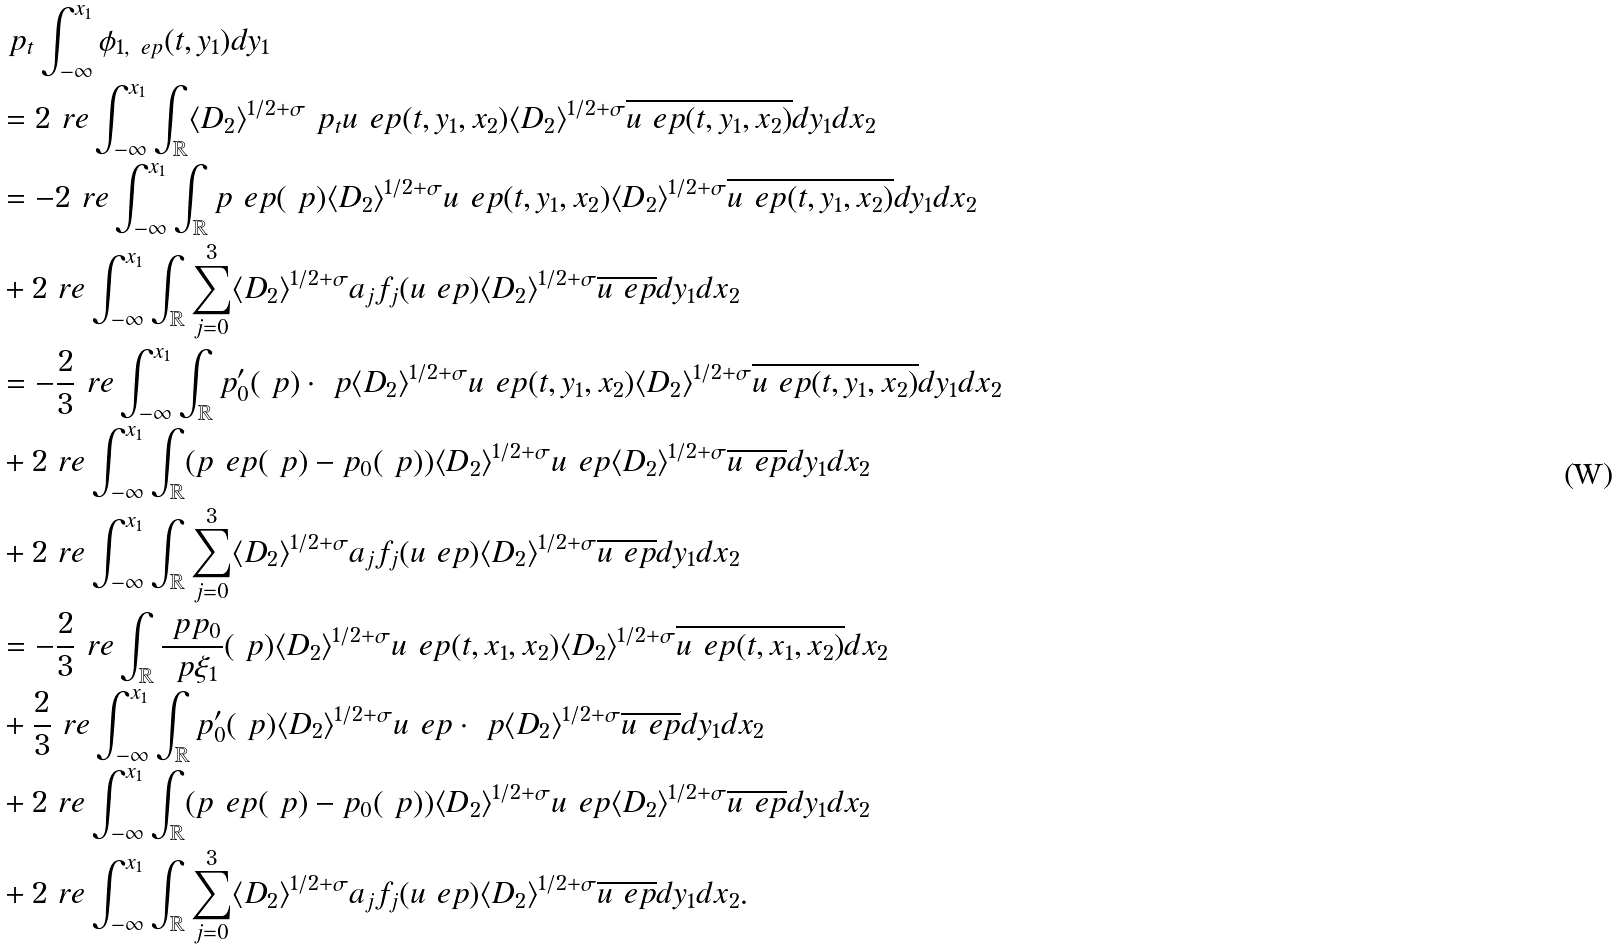<formula> <loc_0><loc_0><loc_500><loc_500>& \ p _ { t } \int _ { - \infty } ^ { x _ { 1 } } \phi _ { 1 , \ e p } ( t , y _ { 1 } ) d y _ { 1 } \\ & = 2 \ r e \int _ { - \infty } ^ { x _ { 1 } } \int _ { \mathbb { R } } \langle { D _ { 2 } } \rangle ^ { 1 / 2 + \sigma } \ p _ { t } u _ { \ } e p ( t , y _ { 1 } , x _ { 2 } ) \langle { D _ { 2 } } \rangle ^ { 1 / 2 + \sigma } \overline { u _ { \ } e p ( t , y _ { 1 } , x _ { 2 } ) } d y _ { 1 } d x _ { 2 } \\ & = - 2 \ r e \int _ { - \infty } ^ { x _ { 1 } } \int _ { \mathbb { R } } p _ { \ } e p ( \ p ) \langle { D _ { 2 } } \rangle ^ { 1 / 2 + \sigma } u _ { \ } e p ( t , y _ { 1 } , x _ { 2 } ) \langle { D _ { 2 } } \rangle ^ { 1 / 2 + \sigma } \overline { u _ { \ } e p ( t , y _ { 1 } , x _ { 2 } ) } d y _ { 1 } d x _ { 2 } \\ & + 2 \ r e \int _ { - \infty } ^ { x _ { 1 } } \int _ { \mathbb { R } } \sum _ { j = 0 } ^ { 3 } \langle { D _ { 2 } } \rangle ^ { 1 / 2 + \sigma } a _ { j } f _ { j } ( u _ { \ } e p ) \langle { D _ { 2 } } \rangle ^ { 1 / 2 + \sigma } \overline { u _ { \ } e p } d y _ { 1 } d x _ { 2 } \\ & = - \frac { 2 } { 3 } \ r e \int _ { - \infty } ^ { x _ { 1 } } \int _ { \mathbb { R } } p _ { 0 } ^ { \prime } ( \ p ) \cdot \ p \langle { D _ { 2 } } \rangle ^ { 1 / 2 + \sigma } u _ { \ } e p ( t , y _ { 1 } , x _ { 2 } ) \langle { D _ { 2 } } \rangle ^ { 1 / 2 + \sigma } \overline { u _ { \ } e p ( t , y _ { 1 } , x _ { 2 } ) } d y _ { 1 } d x _ { 2 } \\ & + 2 \ r e \int _ { - \infty } ^ { x _ { 1 } } \int _ { \mathbb { R } } ( p _ { \ } e p ( \ p ) - p _ { 0 } ( \ p ) ) \langle { D _ { 2 } } \rangle ^ { 1 / 2 + \sigma } u _ { \ } e p \langle { D _ { 2 } } \rangle ^ { 1 / 2 + \sigma } \overline { u _ { \ } e p } d y _ { 1 } d x _ { 2 } \\ & + 2 \ r e \int _ { - \infty } ^ { x _ { 1 } } \int _ { \mathbb { R } } \sum _ { j = 0 } ^ { 3 } \langle { D _ { 2 } } \rangle ^ { 1 / 2 + \sigma } a _ { j } f _ { j } ( u _ { \ } e p ) \langle { D _ { 2 } } \rangle ^ { 1 / 2 + \sigma } \overline { u _ { \ } e p } d y _ { 1 } d x _ { 2 } \\ & = - \frac { 2 } { 3 } \ r e \int _ { \mathbb { R } } \frac { \ p p _ { 0 } } { \ p \xi _ { 1 } } ( \ p ) \langle { D _ { 2 } } \rangle ^ { 1 / 2 + \sigma } u _ { \ } e p ( t , x _ { 1 } , x _ { 2 } ) \langle { D _ { 2 } } \rangle ^ { 1 / 2 + \sigma } \overline { u _ { \ } e p ( t , x _ { 1 } , x _ { 2 } ) } d x _ { 2 } \\ & + \frac { 2 } { 3 } \ r e \int _ { - \infty } ^ { x _ { 1 } } \int _ { \mathbb { R } } p _ { 0 } ^ { \prime } ( \ p ) \langle { D _ { 2 } } \rangle ^ { 1 / 2 + \sigma } u _ { \ } e p \cdot \ p \langle { D _ { 2 } } \rangle ^ { 1 / 2 + \sigma } \overline { u _ { \ } e p } d y _ { 1 } d x _ { 2 } \\ & + 2 \ r e \int _ { - \infty } ^ { x _ { 1 } } \int _ { \mathbb { R } } ( p _ { \ } e p ( \ p ) - p _ { 0 } ( \ p ) ) \langle { D _ { 2 } } \rangle ^ { 1 / 2 + \sigma } u _ { \ } e p \langle { D _ { 2 } } \rangle ^ { 1 / 2 + \sigma } \overline { u _ { \ } e p } d y _ { 1 } d x _ { 2 } \\ & + 2 \ r e \int _ { - \infty } ^ { x _ { 1 } } \int _ { \mathbb { R } } \sum _ { j = 0 } ^ { 3 } \langle { D _ { 2 } } \rangle ^ { 1 / 2 + \sigma } a _ { j } f _ { j } ( u _ { \ } e p ) \langle { D _ { 2 } } \rangle ^ { 1 / 2 + \sigma } \overline { u _ { \ } e p } d y _ { 1 } d x _ { 2 } .</formula> 